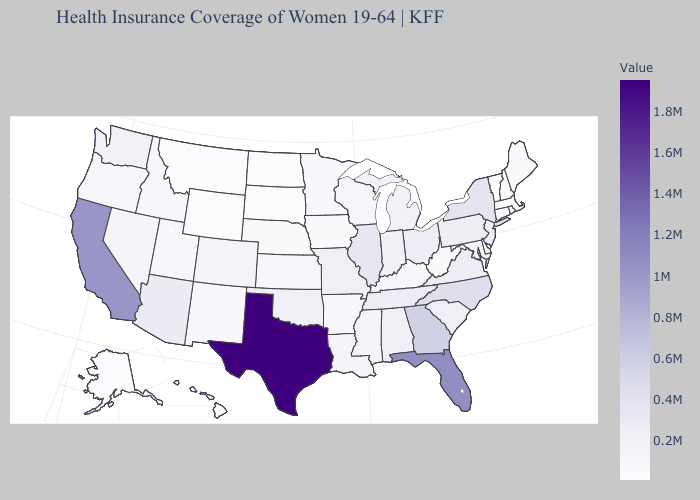Which states hav the highest value in the South?
Give a very brief answer. Texas. Which states have the lowest value in the South?
Quick response, please. Delaware. Among the states that border South Dakota , which have the highest value?
Write a very short answer. Minnesota. Among the states that border Rhode Island , which have the lowest value?
Quick response, please. Massachusetts. 